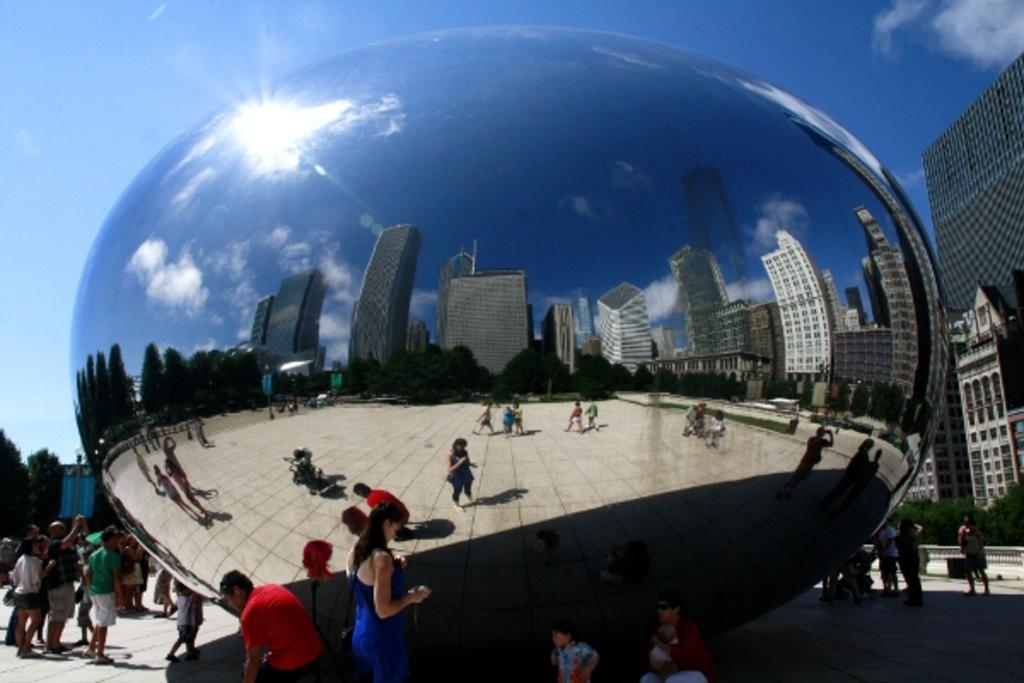What is happening in the image involving people? There is a group of people standing in the image. What can be seen in the image that is a reflection? There are reflections of buildings and trees in the image. What part of the natural environment is visible in the image? The sky is visible in the image. What type of mind can be seen in the image? There is no mind present in the image; it features a group of people standing, reflections of buildings and trees, and the sky. Is there a fan visible in the image? There is no fan present in the image. 